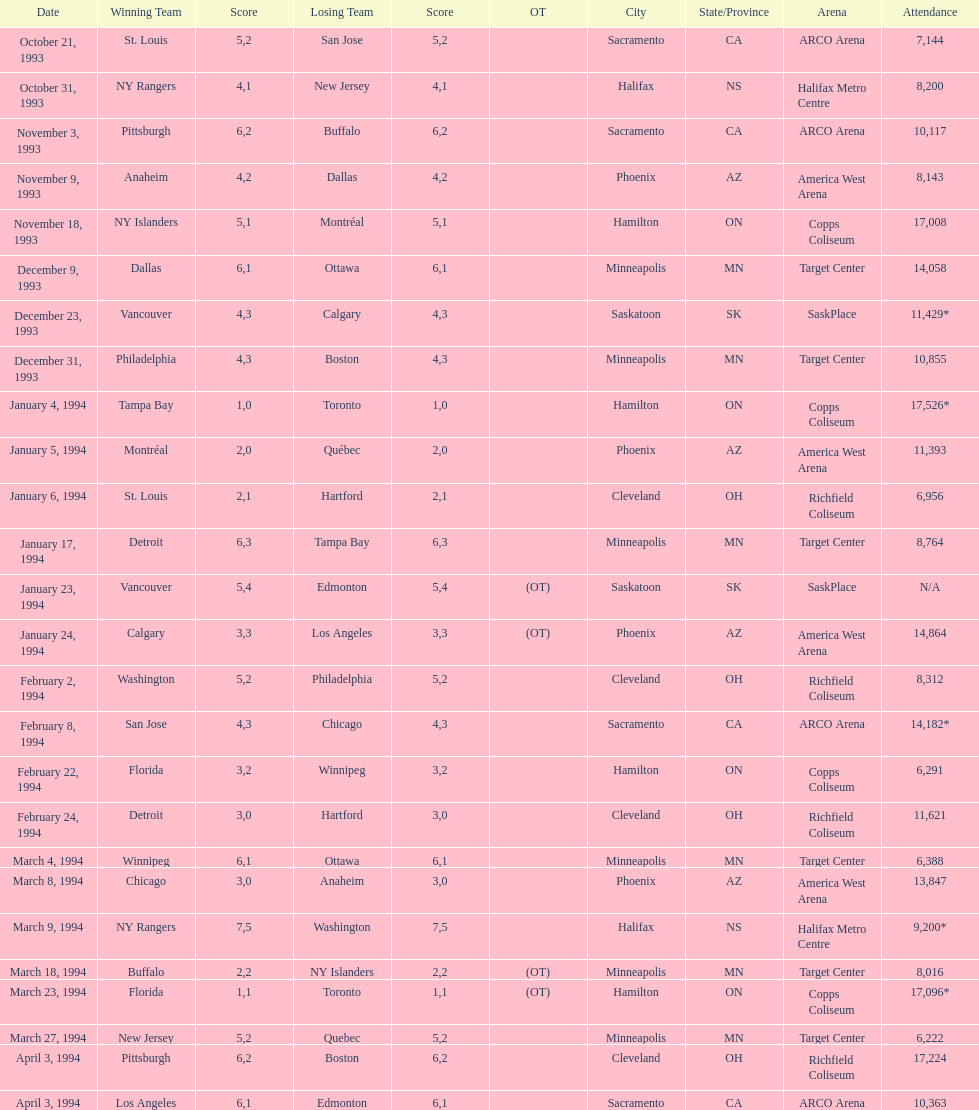When did tampa bay win their first neutral site game? January 4, 1994. 